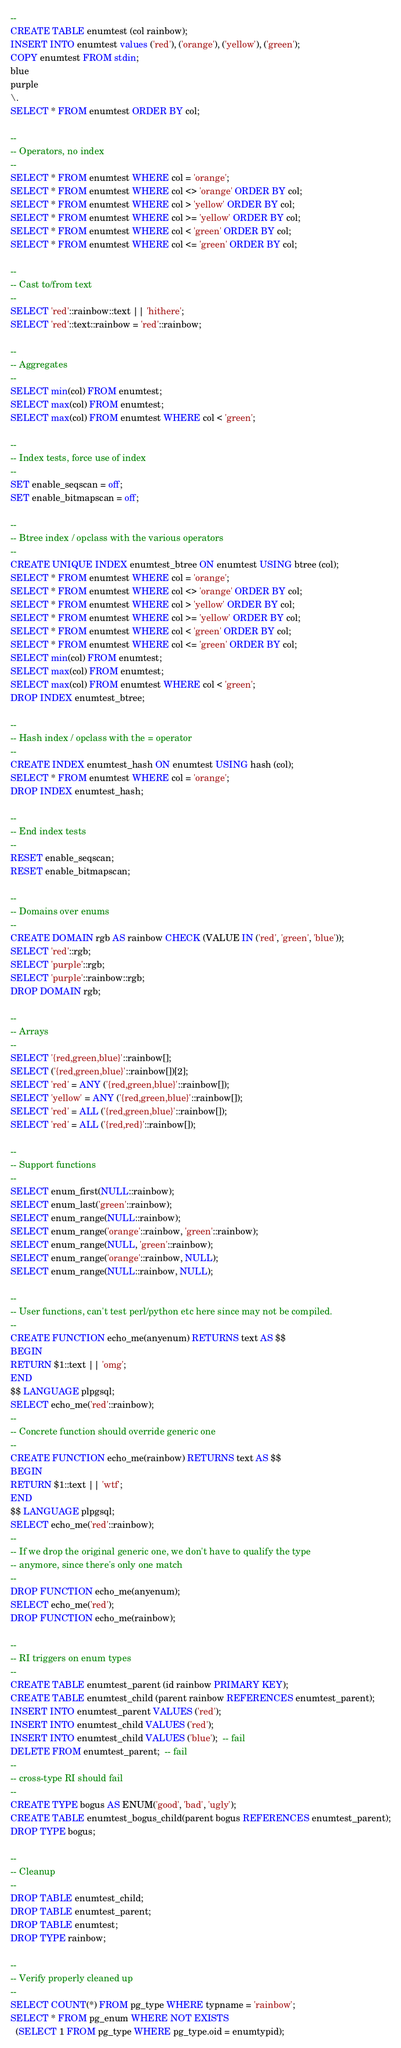<code> <loc_0><loc_0><loc_500><loc_500><_SQL_>--
CREATE TABLE enumtest (col rainbow);
INSERT INTO enumtest values ('red'), ('orange'), ('yellow'), ('green');
COPY enumtest FROM stdin;
blue
purple
\.
SELECT * FROM enumtest ORDER BY col;

--
-- Operators, no index
--
SELECT * FROM enumtest WHERE col = 'orange';
SELECT * FROM enumtest WHERE col <> 'orange' ORDER BY col;
SELECT * FROM enumtest WHERE col > 'yellow' ORDER BY col;
SELECT * FROM enumtest WHERE col >= 'yellow' ORDER BY col;
SELECT * FROM enumtest WHERE col < 'green' ORDER BY col;
SELECT * FROM enumtest WHERE col <= 'green' ORDER BY col;

--
-- Cast to/from text
--
SELECT 'red'::rainbow::text || 'hithere';
SELECT 'red'::text::rainbow = 'red'::rainbow;

--
-- Aggregates
--
SELECT min(col) FROM enumtest;
SELECT max(col) FROM enumtest;
SELECT max(col) FROM enumtest WHERE col < 'green';

--
-- Index tests, force use of index
--
SET enable_seqscan = off;
SET enable_bitmapscan = off;

--
-- Btree index / opclass with the various operators
--
CREATE UNIQUE INDEX enumtest_btree ON enumtest USING btree (col);
SELECT * FROM enumtest WHERE col = 'orange';
SELECT * FROM enumtest WHERE col <> 'orange' ORDER BY col;
SELECT * FROM enumtest WHERE col > 'yellow' ORDER BY col;
SELECT * FROM enumtest WHERE col >= 'yellow' ORDER BY col;
SELECT * FROM enumtest WHERE col < 'green' ORDER BY col;
SELECT * FROM enumtest WHERE col <= 'green' ORDER BY col;
SELECT min(col) FROM enumtest;
SELECT max(col) FROM enumtest;
SELECT max(col) FROM enumtest WHERE col < 'green';
DROP INDEX enumtest_btree;

--
-- Hash index / opclass with the = operator
--
CREATE INDEX enumtest_hash ON enumtest USING hash (col);
SELECT * FROM enumtest WHERE col = 'orange';
DROP INDEX enumtest_hash;

--
-- End index tests
--
RESET enable_seqscan;
RESET enable_bitmapscan;

--
-- Domains over enums
--
CREATE DOMAIN rgb AS rainbow CHECK (VALUE IN ('red', 'green', 'blue'));
SELECT 'red'::rgb;
SELECT 'purple'::rgb;
SELECT 'purple'::rainbow::rgb;
DROP DOMAIN rgb;

--
-- Arrays
--
SELECT '{red,green,blue}'::rainbow[];
SELECT ('{red,green,blue}'::rainbow[])[2];
SELECT 'red' = ANY ('{red,green,blue}'::rainbow[]);
SELECT 'yellow' = ANY ('{red,green,blue}'::rainbow[]);
SELECT 'red' = ALL ('{red,green,blue}'::rainbow[]);
SELECT 'red' = ALL ('{red,red}'::rainbow[]);

--
-- Support functions
--
SELECT enum_first(NULL::rainbow);
SELECT enum_last('green'::rainbow);
SELECT enum_range(NULL::rainbow);
SELECT enum_range('orange'::rainbow, 'green'::rainbow);
SELECT enum_range(NULL, 'green'::rainbow);
SELECT enum_range('orange'::rainbow, NULL);
SELECT enum_range(NULL::rainbow, NULL);

--
-- User functions, can't test perl/python etc here since may not be compiled.
--
CREATE FUNCTION echo_me(anyenum) RETURNS text AS $$
BEGIN
RETURN $1::text || 'omg';
END
$$ LANGUAGE plpgsql;
SELECT echo_me('red'::rainbow);
--
-- Concrete function should override generic one
--
CREATE FUNCTION echo_me(rainbow) RETURNS text AS $$
BEGIN
RETURN $1::text || 'wtf';
END
$$ LANGUAGE plpgsql;
SELECT echo_me('red'::rainbow);
--
-- If we drop the original generic one, we don't have to qualify the type
-- anymore, since there's only one match
--
DROP FUNCTION echo_me(anyenum);
SELECT echo_me('red');
DROP FUNCTION echo_me(rainbow);

--
-- RI triggers on enum types
--
CREATE TABLE enumtest_parent (id rainbow PRIMARY KEY);
CREATE TABLE enumtest_child (parent rainbow REFERENCES enumtest_parent);
INSERT INTO enumtest_parent VALUES ('red');
INSERT INTO enumtest_child VALUES ('red');
INSERT INTO enumtest_child VALUES ('blue');  -- fail
DELETE FROM enumtest_parent;  -- fail
--
-- cross-type RI should fail
--
CREATE TYPE bogus AS ENUM('good', 'bad', 'ugly');
CREATE TABLE enumtest_bogus_child(parent bogus REFERENCES enumtest_parent);
DROP TYPE bogus;

--
-- Cleanup
--
DROP TABLE enumtest_child;
DROP TABLE enumtest_parent;
DROP TABLE enumtest;
DROP TYPE rainbow;

--
-- Verify properly cleaned up
--
SELECT COUNT(*) FROM pg_type WHERE typname = 'rainbow';
SELECT * FROM pg_enum WHERE NOT EXISTS
  (SELECT 1 FROM pg_type WHERE pg_type.oid = enumtypid);
</code> 